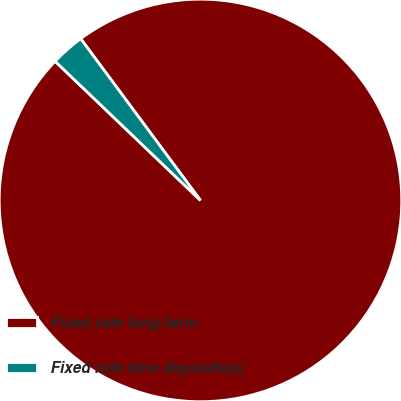Convert chart to OTSL. <chart><loc_0><loc_0><loc_500><loc_500><pie_chart><fcel>Fixed rate long-term<fcel>Fixed rate time deposits(a)<nl><fcel>97.3%<fcel>2.7%<nl></chart> 